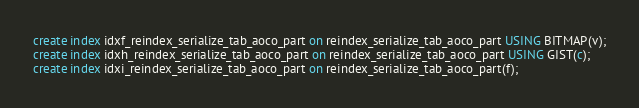<code> <loc_0><loc_0><loc_500><loc_500><_SQL_>create index idxf_reindex_serialize_tab_aoco_part on reindex_serialize_tab_aoco_part USING BITMAP(v);
create index idxh_reindex_serialize_tab_aoco_part on reindex_serialize_tab_aoco_part USING GIST(c);
create index idxi_reindex_serialize_tab_aoco_part on reindex_serialize_tab_aoco_part(f);
</code> 